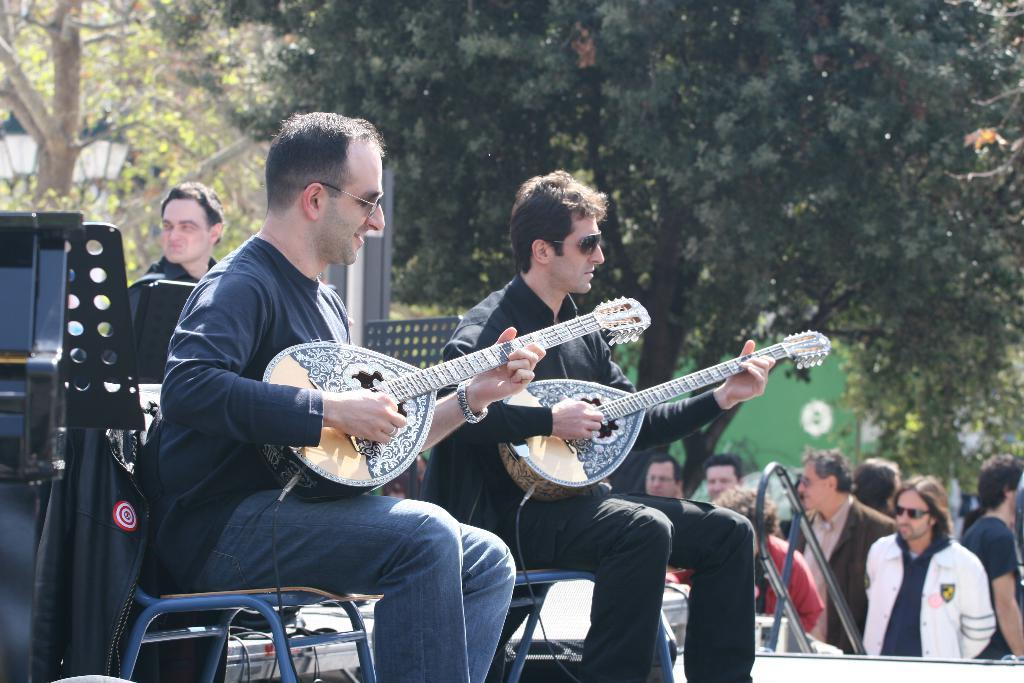How many guitar players are in the image? There are two persons sitting in the image, and they are playing guitar. What are the standing persons doing in the image? The standing persons are watching the guitar players. What can be seen in the background of the image? There are trees visible in the image. What type of pets are sitting with the guitar players in the image? There are no pets visible in the image; only the two guitar players and the standing persons are present. 